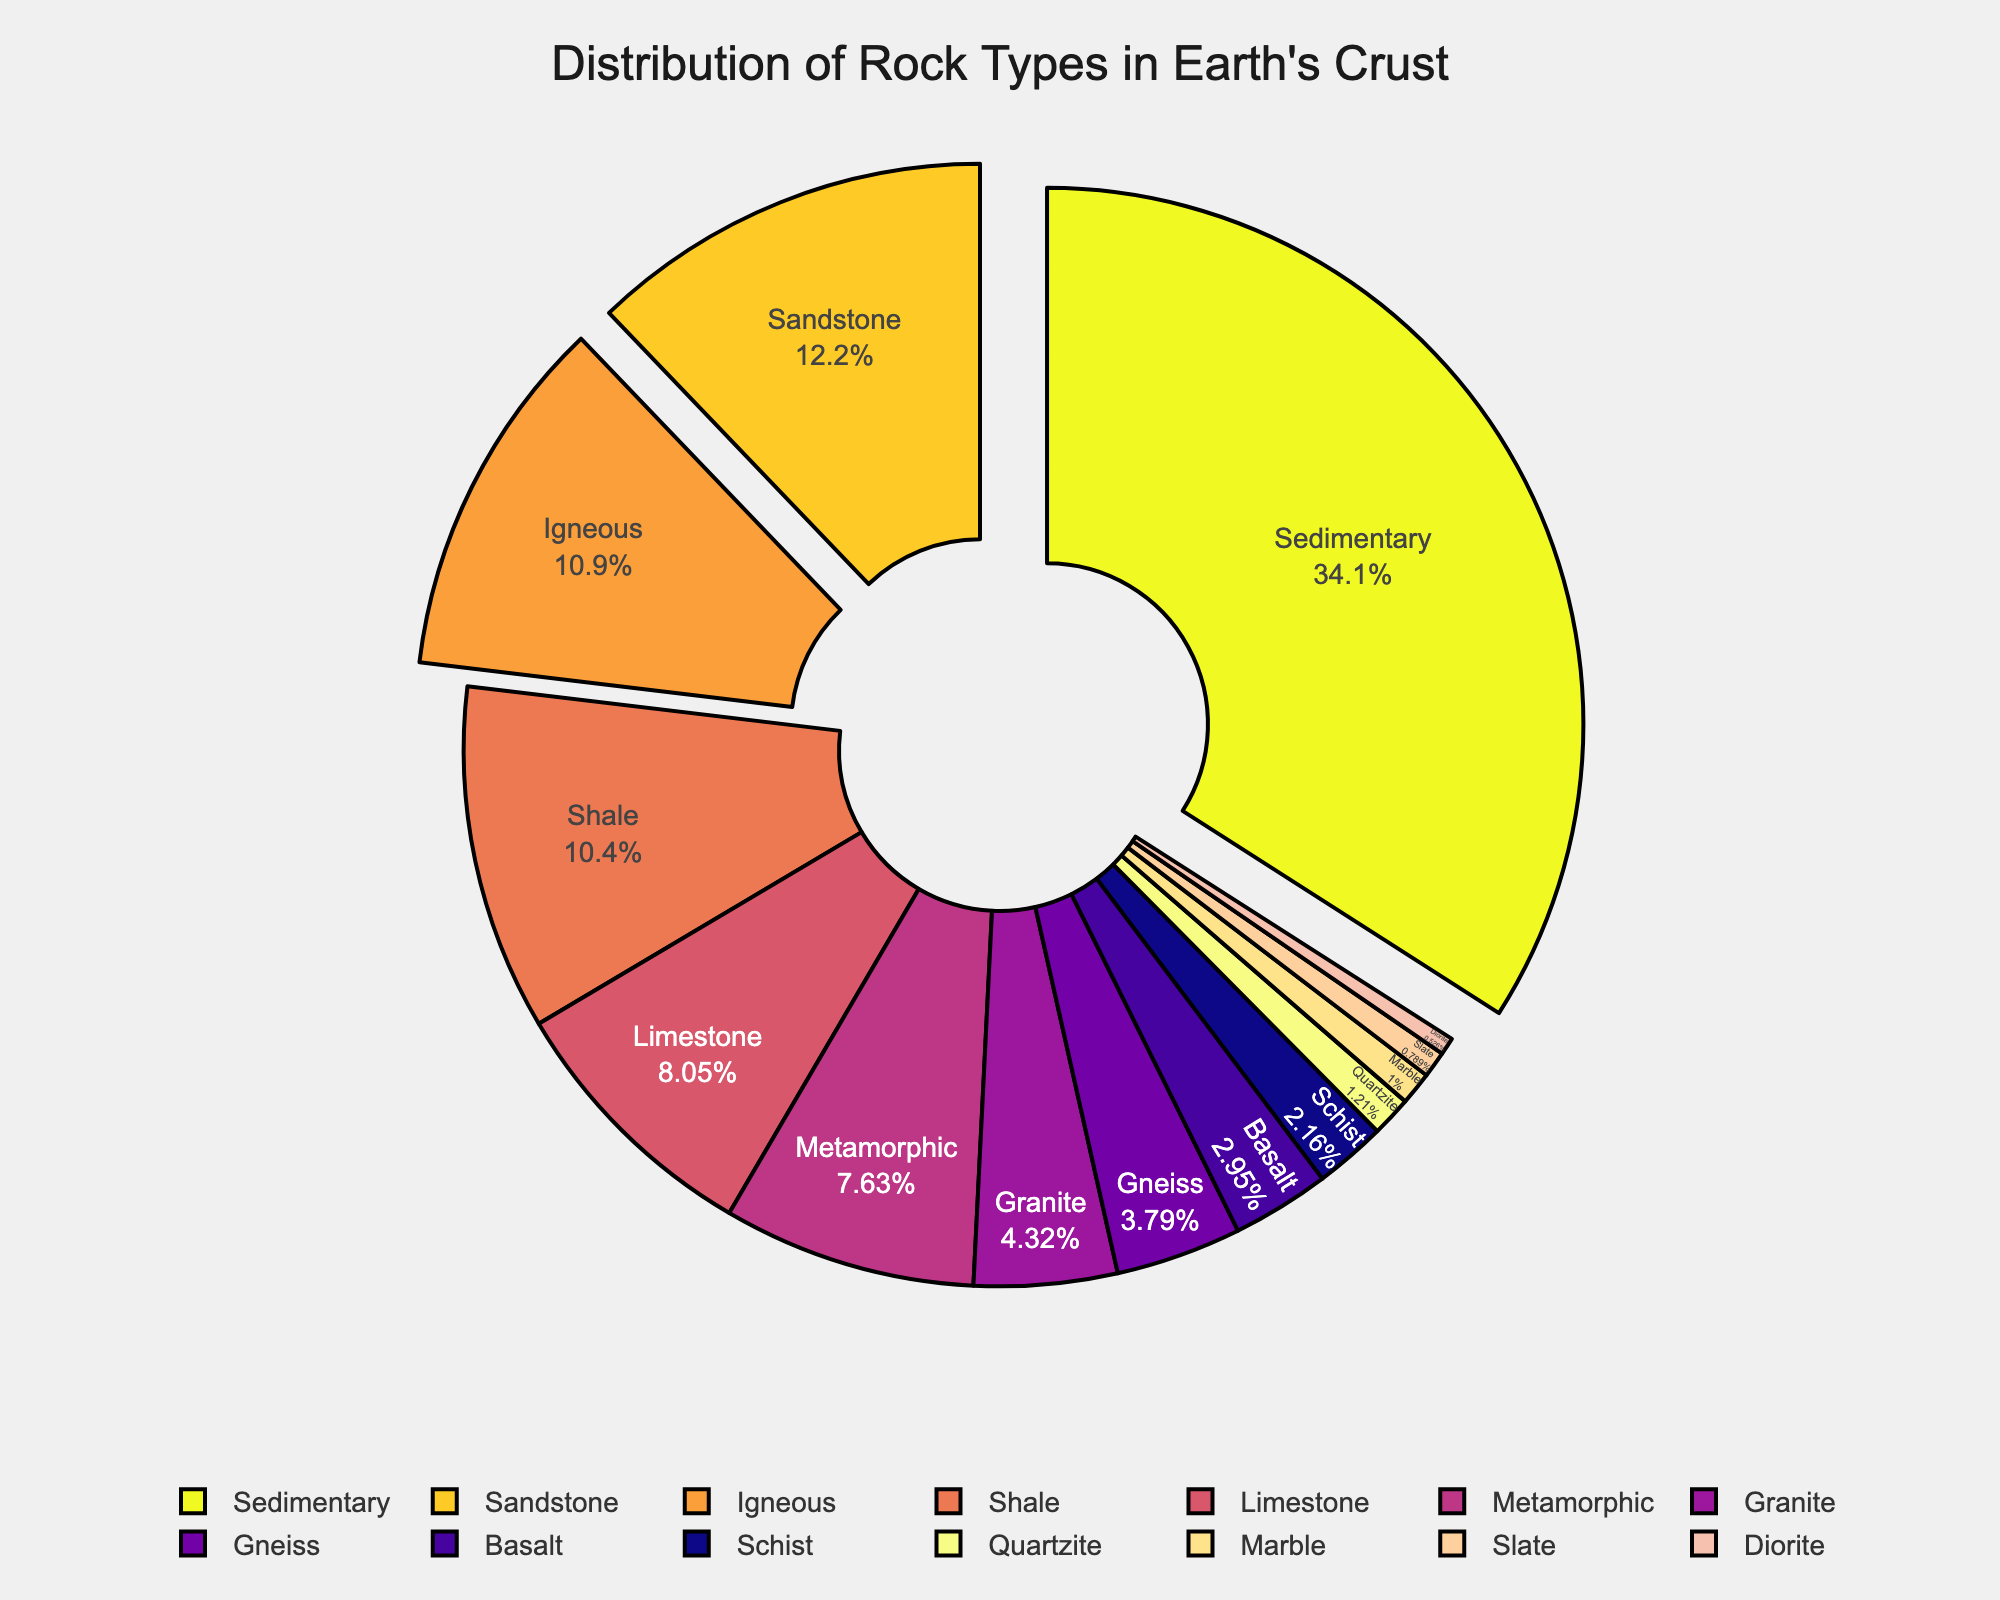what is the percentage of sedimentary rocks in the earth's crust? To find the percentage of sedimentary rocks in the crust, locate the segment labeled "Sedimentary" in the pie chart. The provided data shows it as 64.7%.
Answer: 64.7 Which rock type has the smallest percentage in the Earth's crust? Identify the rock with the smallest segment in the pie chart. According to the data, Slate has the smallest percentage at 1.5%.
Answer: Slate What is the total percentage of metamorphic rocks (Gneiss, Schist, Quartzite, Marble, Slate)? Add the percentages of all metamorphic rocks: Gneiss (7.2) + Schist (4.1) + Quartzite (2.3) + Marble (1.9) + Slate (1.5) = 17.0%.
Answer: 17.0 Is the percentage of sedimentary rocks higher than the combined percentage of igneous and metamorphic rocks? Calculate the total percentage of igneous and metamorphic rocks: (Igneous 20.8 + Granite 8.2 + Basalt 5.6 + Diorite 1.0) + Metamorphic (14.5) = 50.1%. Since 64.7% is greater than 50.1%, the answer is yes.
Answer: Yes Which has a higher percentage, granite or basalt? Compare the segments labeled Granite (8.2%) and Basalt (5.6%). Granite has the higher percentage.
Answer: Granite How much higher is the percentage of sandstone compared to limestone? Subtract Limestone's percentage (15.3) from Sandstone's percentage (23.1): 23.1 - 15.3 = 7.8%.
Answer: 7.8 What is the percentage difference between the two largest rock types? The largest is Sedimentary (64.7%) and the second largest is Sandstone (23.1%). Subtract their percentages: 64.7 - 23.1 = 41.6%.
Answer: 41.6 What is the combined percentage of the three smallest rock types? Add the percentages of the three smallest rock types: Slate (1.5) + Diorite (1.0) + Marble (1.9) = 4.4%.
Answer: 4.4 Do the different igneous rocks combined (Igneous, Granite, Basalt, Diorite) represent more than one-fourth of the Earth's crust? Calculate the combined percentage of the igneous rocks: Igneous (20.8) + Granite (8.2) + Basalt (5.6) + Diorite (1.0) = 35.6%. Since 35.6% is more than 25%, the answer is yes.
Answer: Yes 